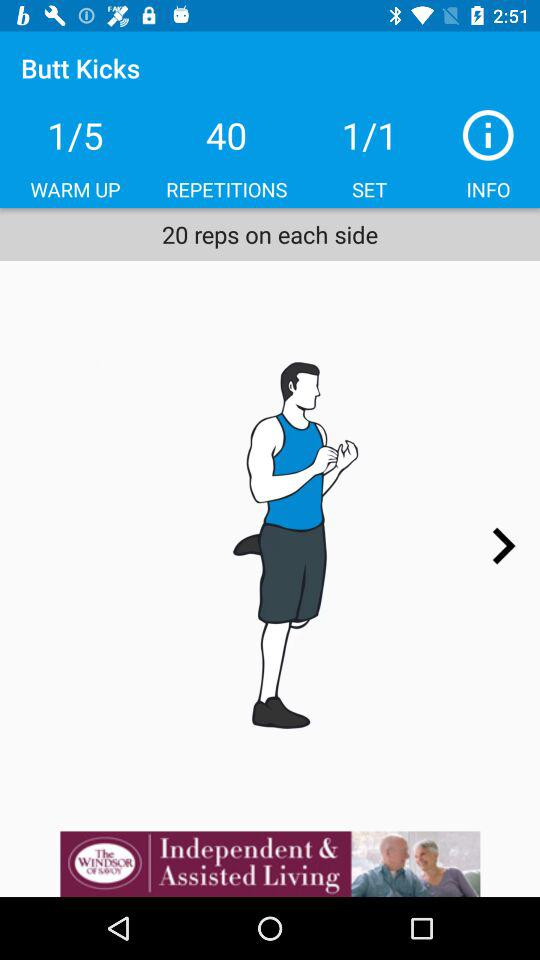How many repetitions are there? There are 40 repetitions. 